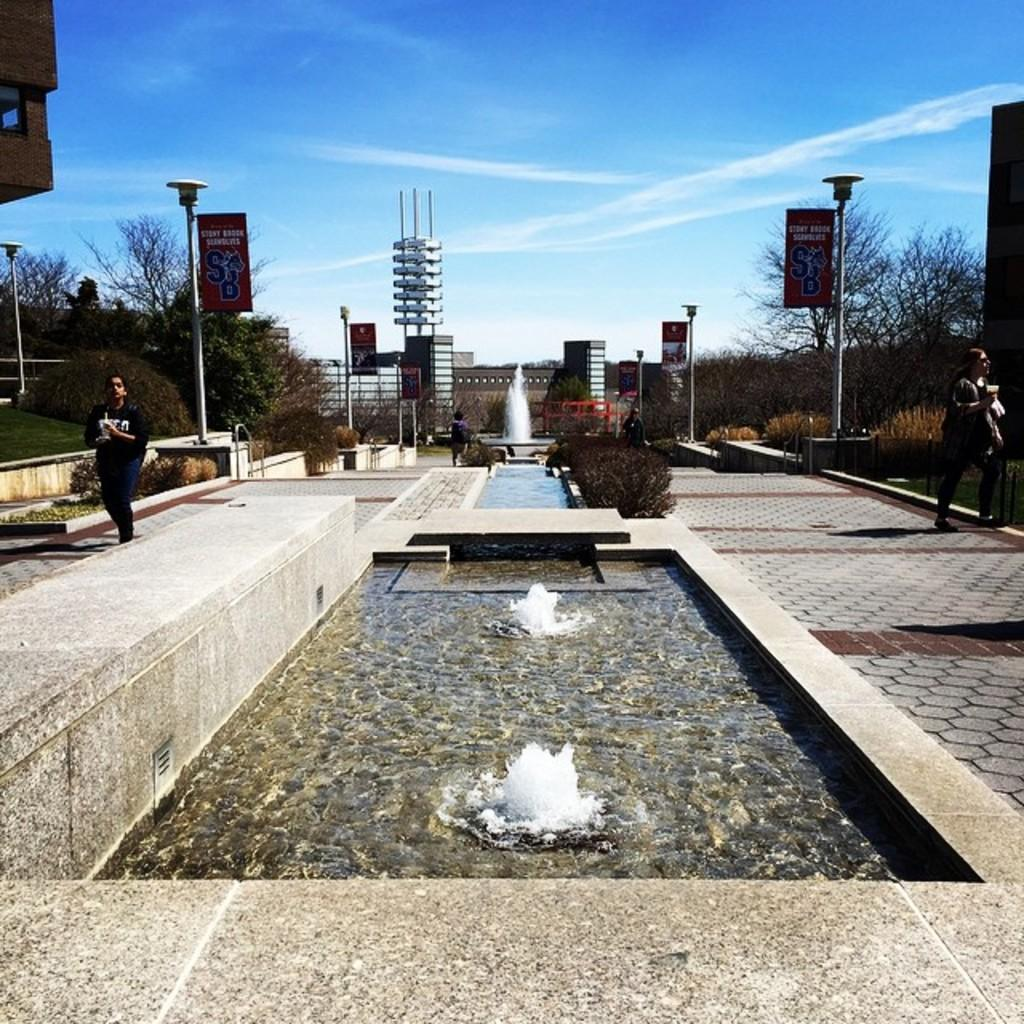What is the main feature in the center of the image? There is a fountain in the center of the image. What are the people in the image doing? The people walking in the image. What can be seen in the background of the image? There are poles, trees, boards, and the sky visible in the background of the image. What type of history can be seen in the image? There is no specific historical event or reference visible in the image. Can you see a ship in the image? There is no ship present in the image. Is there a yak in the image? There is no yak present in the image. 